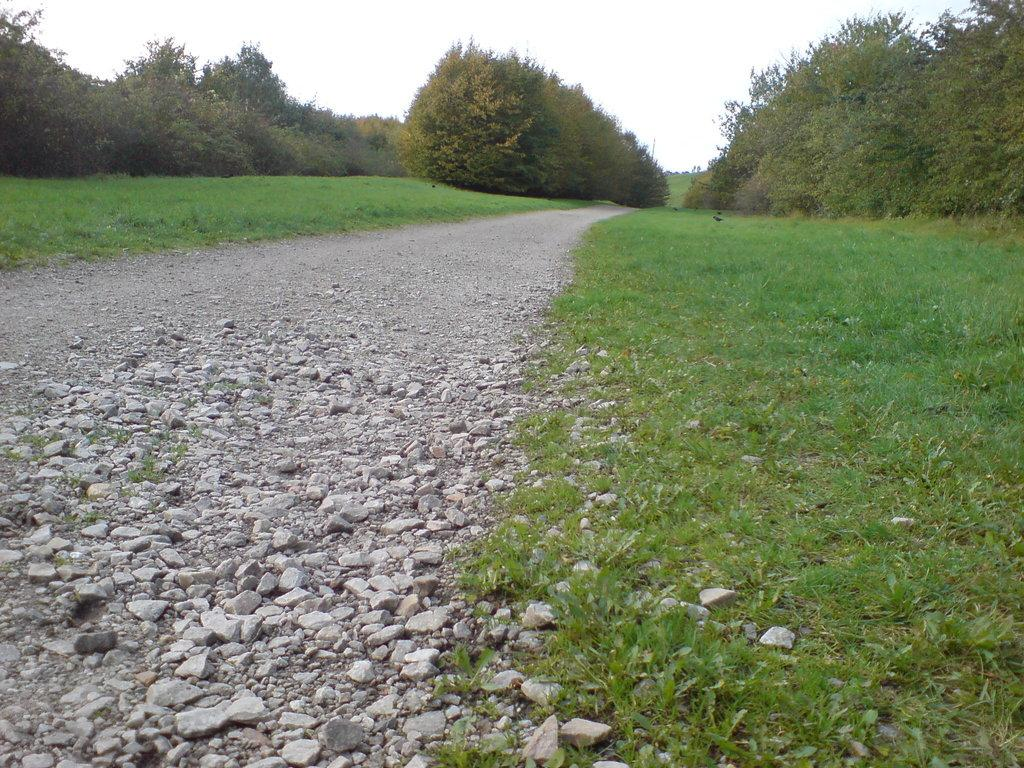What is the main feature of the image? There is a path in the image. How is the path situated in relation to the surrounding environment? The path is in between grass. What can be seen around the path? There are trees visible around the path. What type of butter is being used to maintain the condition of the path in the image? There is no butter present in the image, and the condition of the path is not mentioned. 